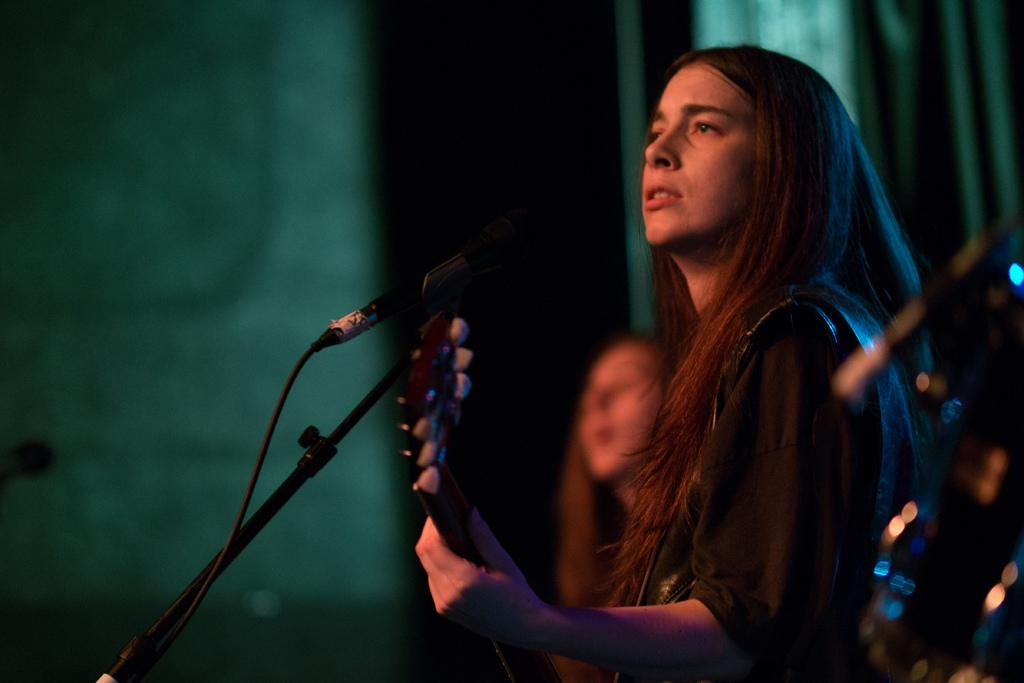Who is the main subject in the image? There is a woman in the image. What is the woman holding in the image? The woman is holding an object, which appears to be a microphone. Can you describe the person standing behind the woman? There is a person standing behind the woman, but their appearance or actions are not specified in the provided facts. What type of debt is the woman discussing with the person behind her in the image? There is no mention of debt or any discussion in the image. The woman is holding a microphone, which suggests she might be speaking or performing, but there is no indication of the topic or context of her actions. 